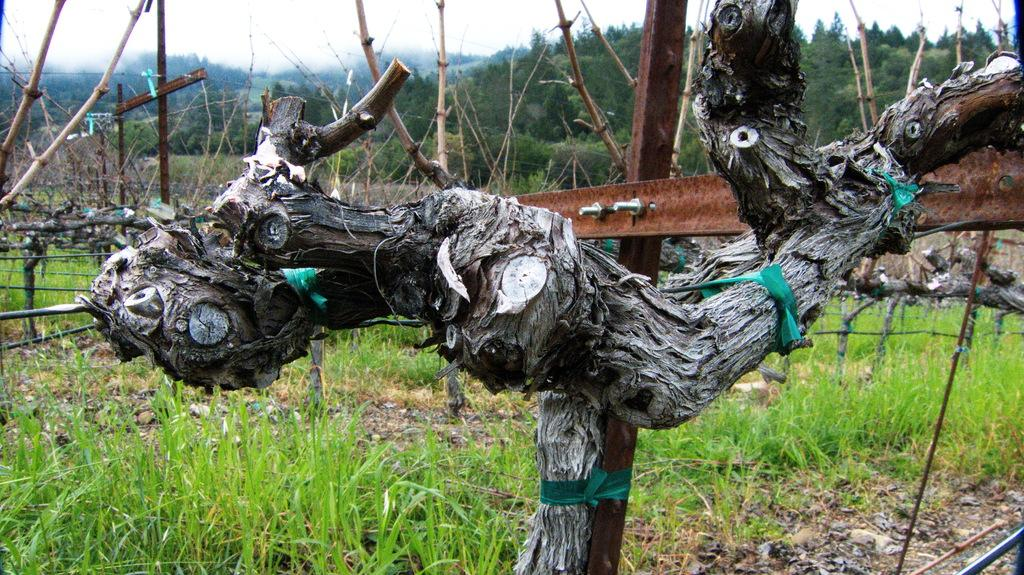What is the main object in the image? There is a tree trunk in the image. What else can be seen in the image besides the tree trunk? There is fencing and grass present in the image. Are there any other trees visible in the image? Yes, there are trees in the image. What thought is the zebra having while standing near the tree trunk in the image? There is no zebra present in the image, so it is not possible to determine any thoughts it might have. 